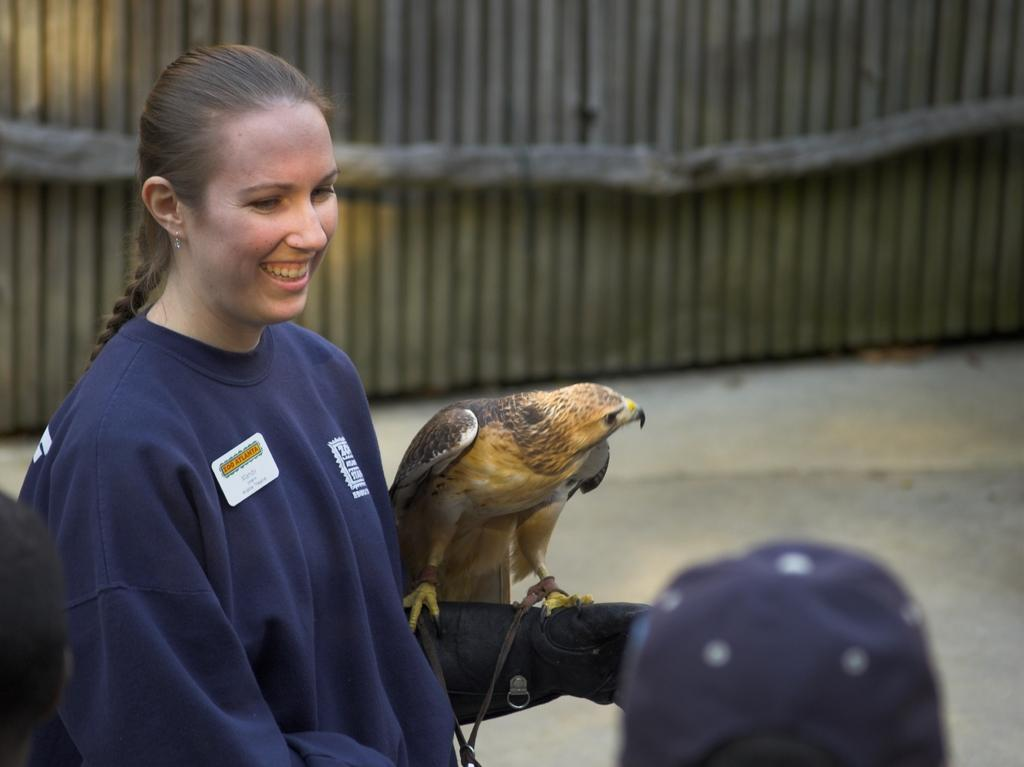Who is in the image? There is a girl in the image. What is the girl doing in the image? The girl is laughing in the image. What is the girl wearing in the image? The girl is wearing a blue sweater in the image. What animal can be seen in the image? There is an eagle in the image. What type of frame is visible in the image? There is a wooden frame visible in the image. What type of toothbrush is the girl using in the image? There is no toothbrush present in the image. How does the girl express division in the image? The girl does not express division in the image; she is laughing and there is no indication of any division-related activity. 